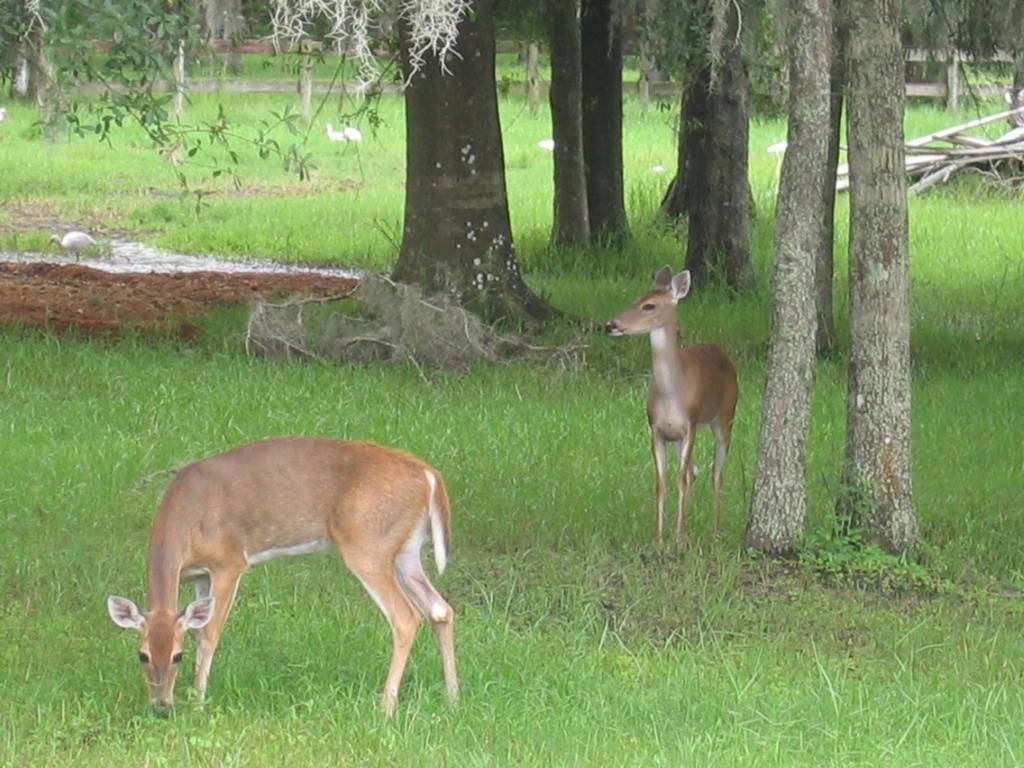What types of living creatures can be seen in the image? There are animals and birds in the image. Where are the animals and birds located in the image? The animals and birds are on the ground in the image. What type of vegetation is visible in the image? There is grass visible in the image. What part of the trees can be seen in the image? The bark of trees is present in the image. What structures are visible in the image? There are poles in the image. What other natural elements are present in the image? There are trees in the image. What type of produce can be seen growing on the cushion in the image? There is no cushion or produce present in the image. 